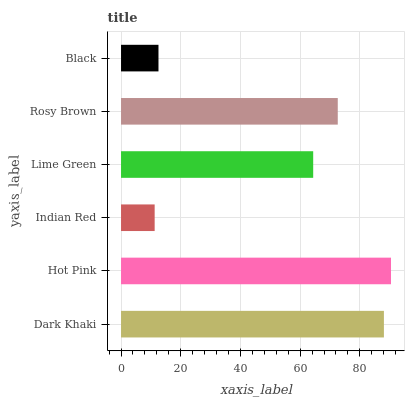Is Indian Red the minimum?
Answer yes or no. Yes. Is Hot Pink the maximum?
Answer yes or no. Yes. Is Hot Pink the minimum?
Answer yes or no. No. Is Indian Red the maximum?
Answer yes or no. No. Is Hot Pink greater than Indian Red?
Answer yes or no. Yes. Is Indian Red less than Hot Pink?
Answer yes or no. Yes. Is Indian Red greater than Hot Pink?
Answer yes or no. No. Is Hot Pink less than Indian Red?
Answer yes or no. No. Is Rosy Brown the high median?
Answer yes or no. Yes. Is Lime Green the low median?
Answer yes or no. Yes. Is Indian Red the high median?
Answer yes or no. No. Is Black the low median?
Answer yes or no. No. 